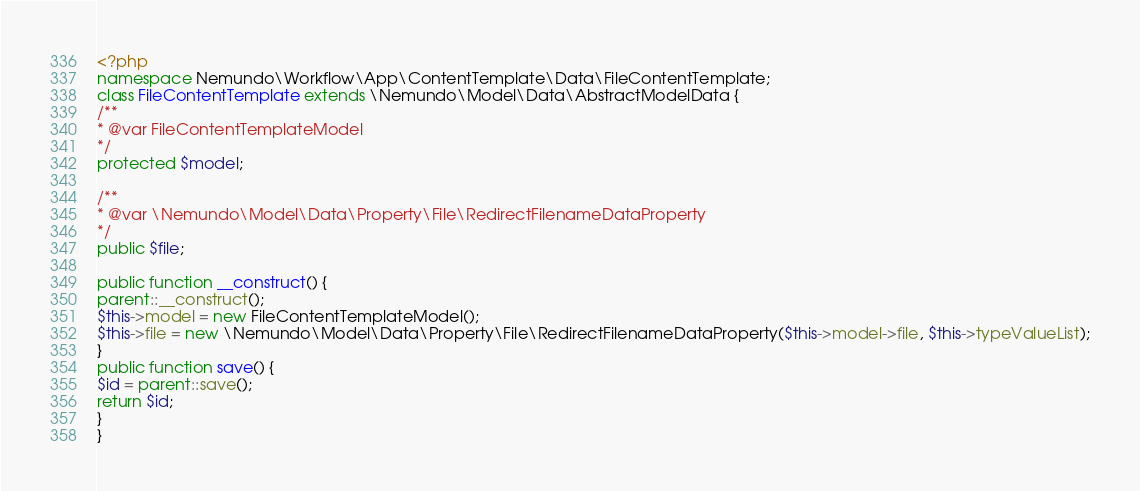<code> <loc_0><loc_0><loc_500><loc_500><_PHP_><?php
namespace Nemundo\Workflow\App\ContentTemplate\Data\FileContentTemplate;
class FileContentTemplate extends \Nemundo\Model\Data\AbstractModelData {
/**
* @var FileContentTemplateModel
*/
protected $model;

/**
* @var \Nemundo\Model\Data\Property\File\RedirectFilenameDataProperty
*/
public $file;

public function __construct() {
parent::__construct();
$this->model = new FileContentTemplateModel();
$this->file = new \Nemundo\Model\Data\Property\File\RedirectFilenameDataProperty($this->model->file, $this->typeValueList);
}
public function save() {
$id = parent::save();
return $id;
}
}</code> 